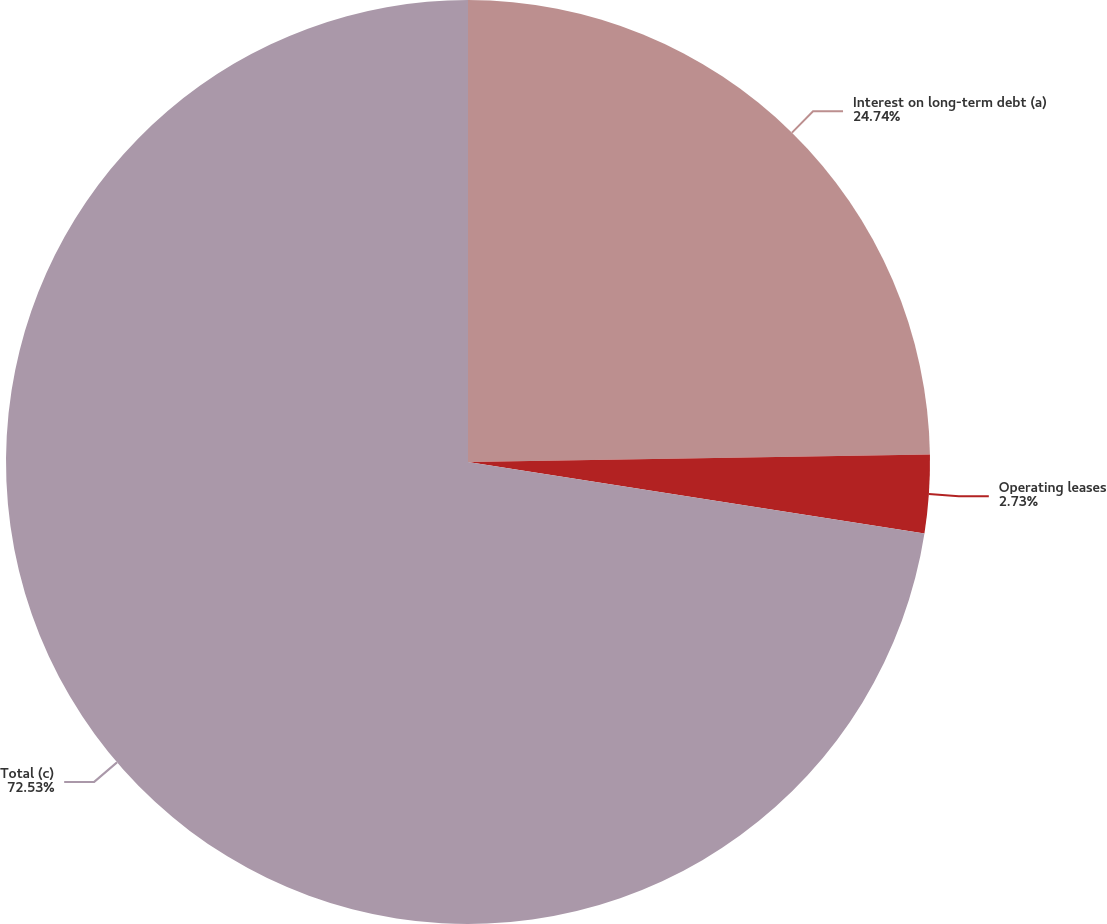Convert chart. <chart><loc_0><loc_0><loc_500><loc_500><pie_chart><fcel>Interest on long-term debt (a)<fcel>Operating leases<fcel>Total (c)<nl><fcel>24.74%<fcel>2.73%<fcel>72.53%<nl></chart> 